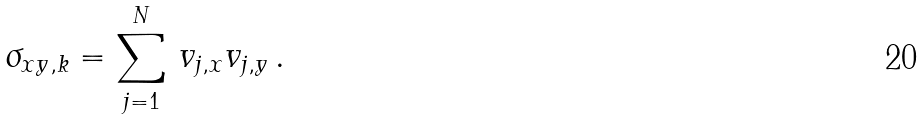<formula> <loc_0><loc_0><loc_500><loc_500>\sigma _ { x y , k } = \sum _ { j = 1 } ^ { N } \, v _ { j , x } v _ { j , y } \, .</formula> 